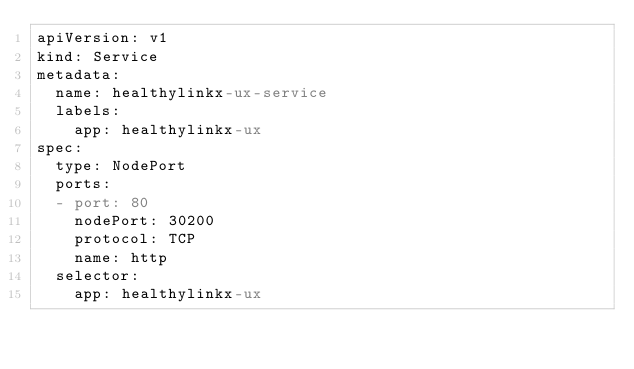Convert code to text. <code><loc_0><loc_0><loc_500><loc_500><_YAML_>apiVersion: v1
kind: Service
metadata:
  name: healthylinkx-ux-service
  labels:
    app: healthylinkx-ux
spec:
  type: NodePort
  ports:
  - port: 80
    nodePort: 30200
    protocol: TCP
    name: http
  selector:
    app: healthylinkx-ux</code> 